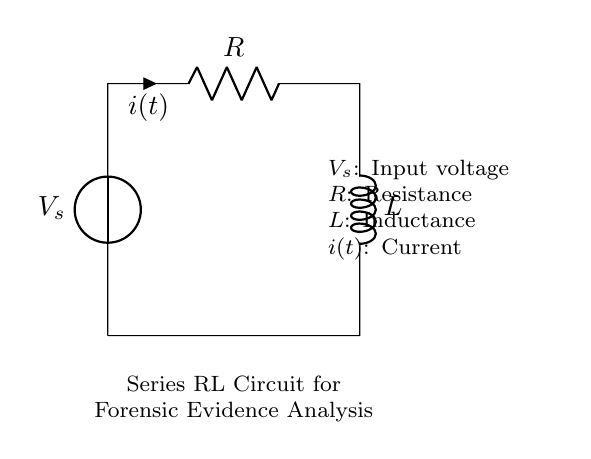What is the type of the main components in the circuit? The circuit includes a resistor and an inductor, identified by the labels R and L in the diagram.
Answer: Resistor and Inductor What does the input voltage represent in this circuit? The input voltage, labeled as V_s, represents the source of electrical energy supplied to the series RL circuit.
Answer: Source of electrical energy What is the relationship between current and voltage in this RL circuit? In a series RL circuit, the voltage across the components leads to a current that increases or decreases depending on the applied voltage and the inductance; this is characterized by the time constant.
Answer: Depends on applied voltage and inductance What is the total impedance of this RL series circuit? The total impedance can be computed as the square root of the sum of the squares of the resistance and inductive reactance, which includes both R and the frequency-dependent inductor value.
Answer: Square root of the sum of squares of resistance and inductive reactance What happens to the current if the resistance is increased? Increasing the resistance results in a decrease in the current flowing through the circuit, assuming the input voltage remains constant; this follows Ohm's Law.
Answer: Current decreases How does inductance affect the behavior of the circuit during switching? Higher inductance leads to a slower change in current through the circuit upon switching, as the inductor opposes rapid changes in current due to its magnetic field.
Answer: Slower change in current What role does the resistor play in the series RL circuit? The resistor controls the current flow and dissipates energy in the form of heat, also influencing the time constant of the circuit.
Answer: Controls current flow 